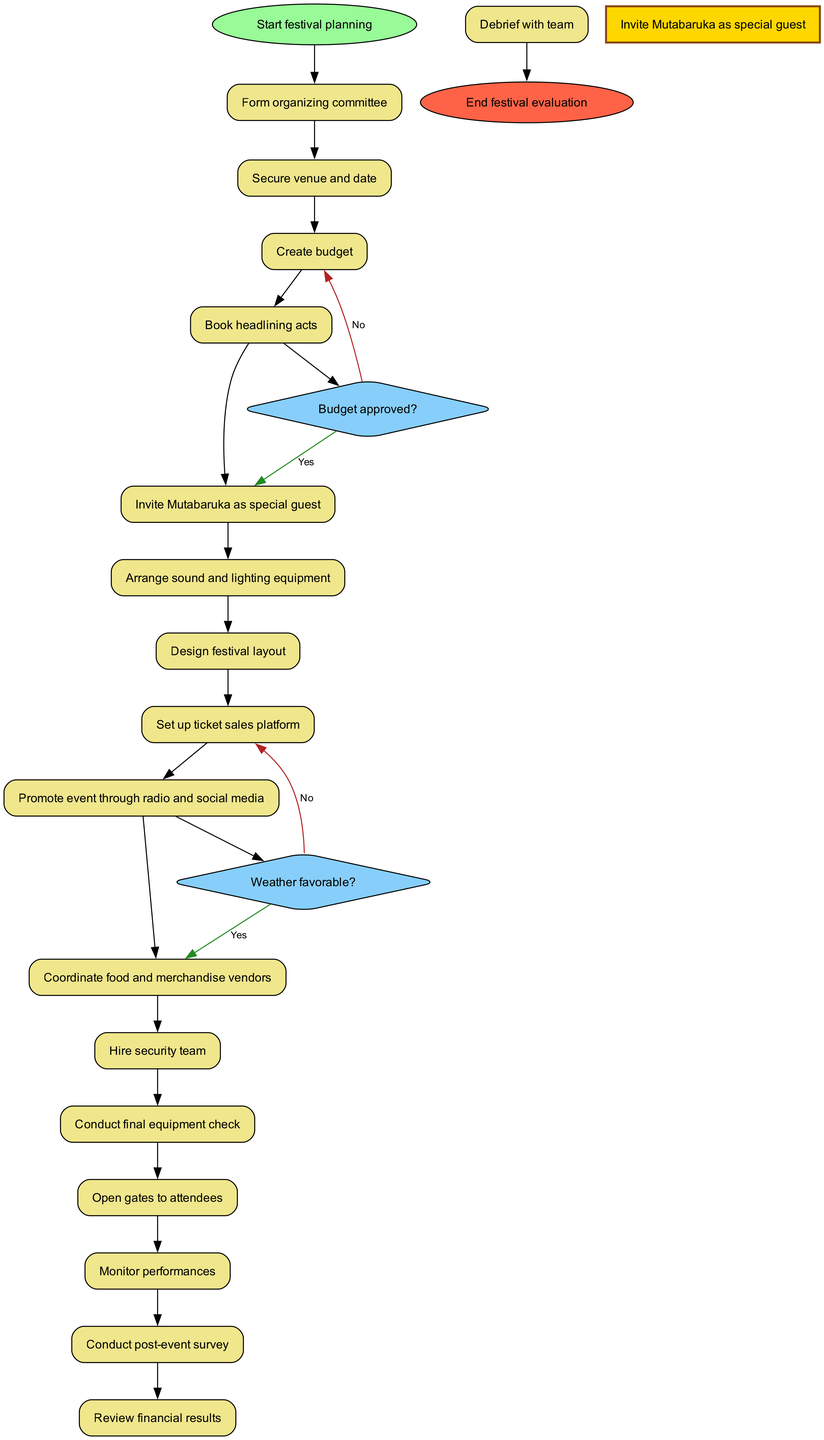What is the first activity in the workflow? The diagram lists "Start festival planning" as the initial node, and the first activity listed after this is "Form organizing committee."
Answer: Form organizing committee How many decision points are present in the diagram? There are two decision points: "Budget approved?" and "Weather favorable?" Thus, the total count of decision nodes is two.
Answer: 2 What activity follows immediately after "Book headlining acts"? Referring to the flow of activities in the diagram, "Invite Mutabaruka as special guest" occurs directly after "Book headlining acts."
Answer: Invite Mutabaruka as special guest What is the consequence of a "No" answer to the "Budget approved?" decision? Following the decision node, if the answer to "Budget approved?" is "No," the next activity directs back to "Revise budget," indicating a need to rework the budget before proceeding.
Answer: Revise budget Which activity is designated to happen just before opening the gates to attendees? The activity that precedes "Open gates to attendees" is "Conduct final equipment check," ensuring everything is properly set up and functioning.
Answer: Conduct final equipment check What is the final node in the workflow? The last node in the activity diagram signifies the completion of the entire workflow, which is "End festival evaluation."
Answer: End festival evaluation How many activities are there before the vendor coordination? The activity "Coordinate food and merchandise vendors" comes after six activities: "Form organizing committee", "Secure venue and date", "Create budget", "Book headlining acts", "Invite Mutabaruka as special guest", and "Arrange sound and lighting equipment." Thus, before vendor coordination, there are six activities.
Answer: 6 What action is taken if the weather is not favorable? If the answer to the "Weather favorable?" decision is "No," the flow indicates that a "contingency plan" will be implemented, which outlines an alternative approach to proceed with the festival.
Answer: Implement contingency plan 